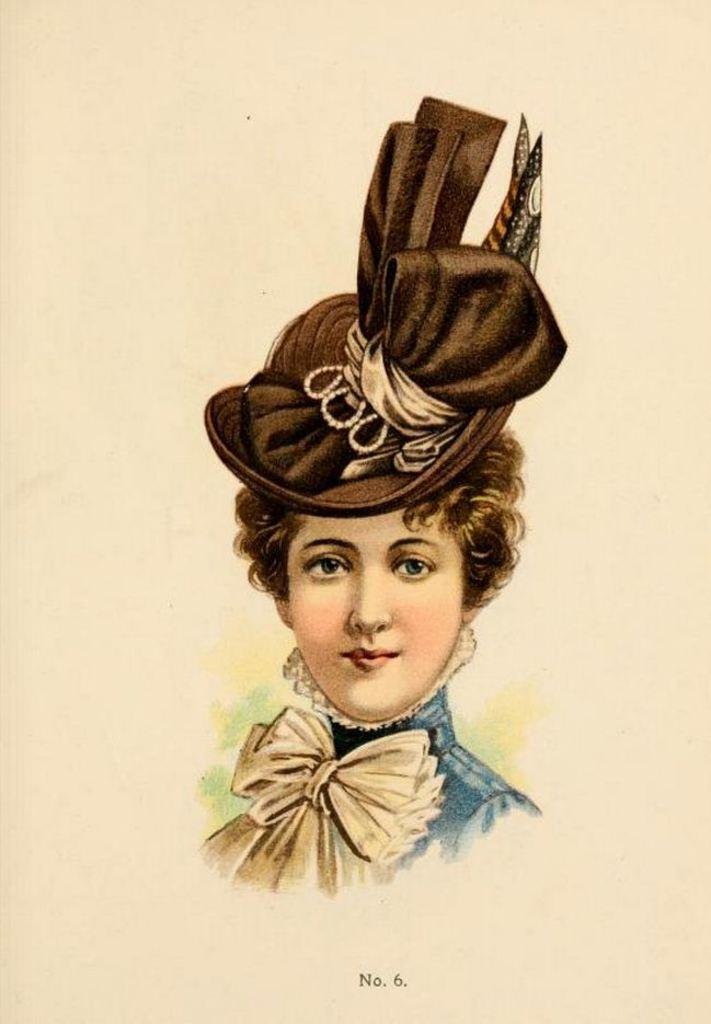Describe this image in one or two sentences. In the picture I can see a painting of a woman. The woman is wearing a hat and some other objects. I can also see something written on the image. 